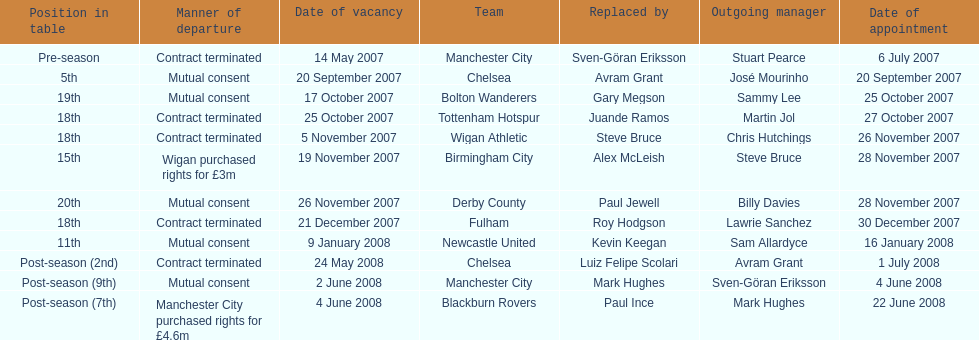What team is listed after manchester city? Chelsea. 